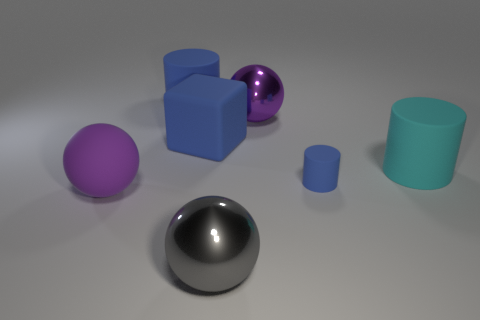Is the big blue object that is in front of the big blue cylinder made of the same material as the sphere behind the large cyan matte object? The big blue object in front of the cylinder and the sphere behind the large cyan matte object appear to have different reflective properties. The sphere exhibits a shiny, reflective surface indicating metallic or glossy finish, whereas the big blue objects seem to have a matte finish, suggesting they could be made from a material that diffuses light rather than reflecting it sharply, like plastic or painted metal. 